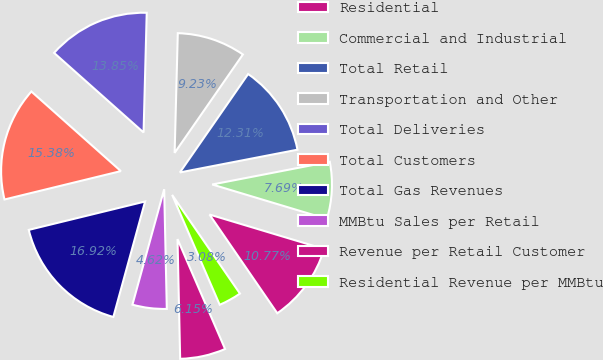Convert chart. <chart><loc_0><loc_0><loc_500><loc_500><pie_chart><fcel>Residential<fcel>Commercial and Industrial<fcel>Total Retail<fcel>Transportation and Other<fcel>Total Deliveries<fcel>Total Customers<fcel>Total Gas Revenues<fcel>MMBtu Sales per Retail<fcel>Revenue per Retail Customer<fcel>Residential Revenue per MMBtu<nl><fcel>10.77%<fcel>7.69%<fcel>12.31%<fcel>9.23%<fcel>13.85%<fcel>15.38%<fcel>16.92%<fcel>4.62%<fcel>6.15%<fcel>3.08%<nl></chart> 